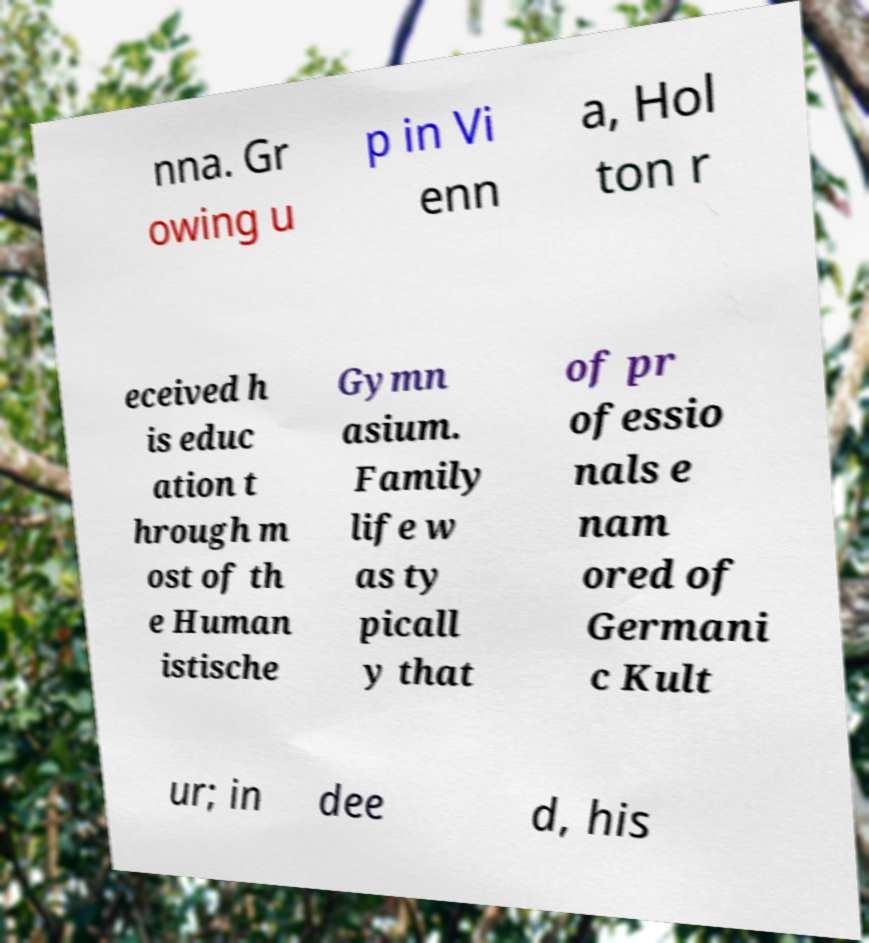For documentation purposes, I need the text within this image transcribed. Could you provide that? nna. Gr owing u p in Vi enn a, Hol ton r eceived h is educ ation t hrough m ost of th e Human istische Gymn asium. Family life w as ty picall y that of pr ofessio nals e nam ored of Germani c Kult ur; in dee d, his 